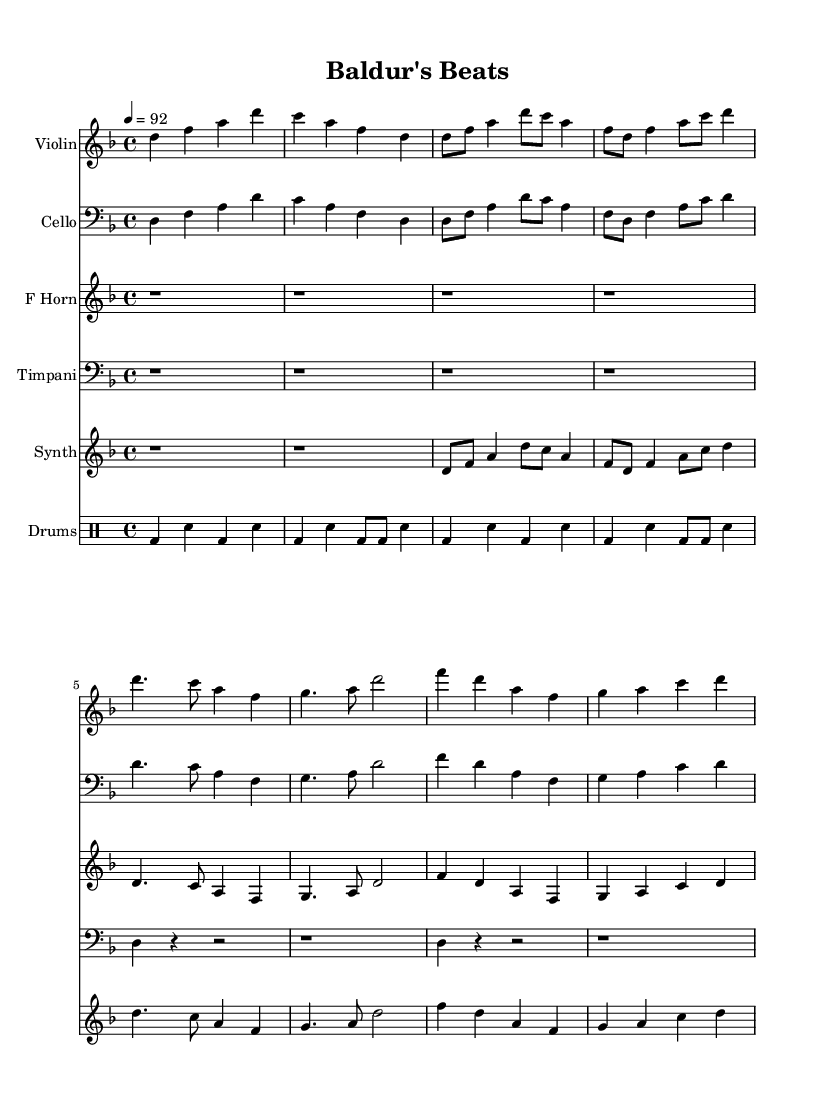What is the key signature of this music? The key signature for this composition is D minor, which has one flat (B flat). This can be determined from the key signature indicated at the beginning of the music sheet.
Answer: D minor What is the time signature of this music? The time signature is 4/4, which means there are four beats in each measure and a quarter note receives one beat. This is indicated at the beginning of the score next to the key signature.
Answer: 4/4 What is the tempo marking of this piece? The tempo marking is 92 beats per minute, as indicated by the tempo directive. This sets the pace of the piece and is often shown with a metronome marking in the score.
Answer: 92 How many lines are in the drum staff? There are five lines in the drum staff. The standard drum staff is similar to a regular treble or bass staff but usually has specific notations for different percussion instruments.
Answer: Five Which instrument has a dotted half note in measure 5? The instrument with a dotted half note in measure 5 is the French Horn. By examining the music, you can find that the French Horn has a dotted half note in that specific measure while other instruments have different notes.
Answer: French Horn What rhythmic pattern in the drum machine indicates the genre influences? The drum machine utilizes a consistent backbeat with bass drum and snare patterns which is characteristic of Hip Hop. The alternating bass and snare drum patterns create a solid rhythmic foundation typical in Hip Hop production.
Answer: Backbeat Which string instrument plays the highest pitch in this score? The Violin plays the highest pitch in this score. By analyzing the notes on each staff, the Violin consistently features higher pitches compared to the Cello, French Horn, and Timpani.
Answer: Violin 